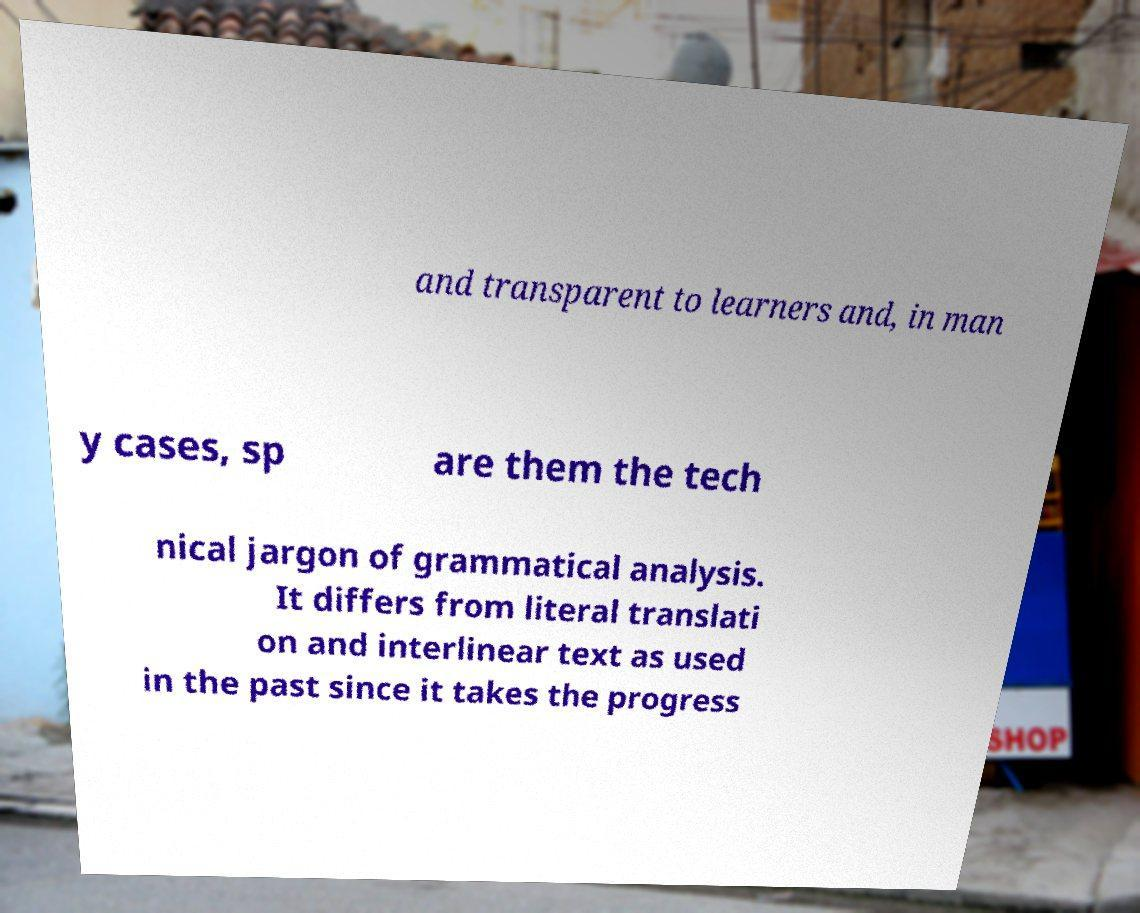For documentation purposes, I need the text within this image transcribed. Could you provide that? and transparent to learners and, in man y cases, sp are them the tech nical jargon of grammatical analysis. It differs from literal translati on and interlinear text as used in the past since it takes the progress 